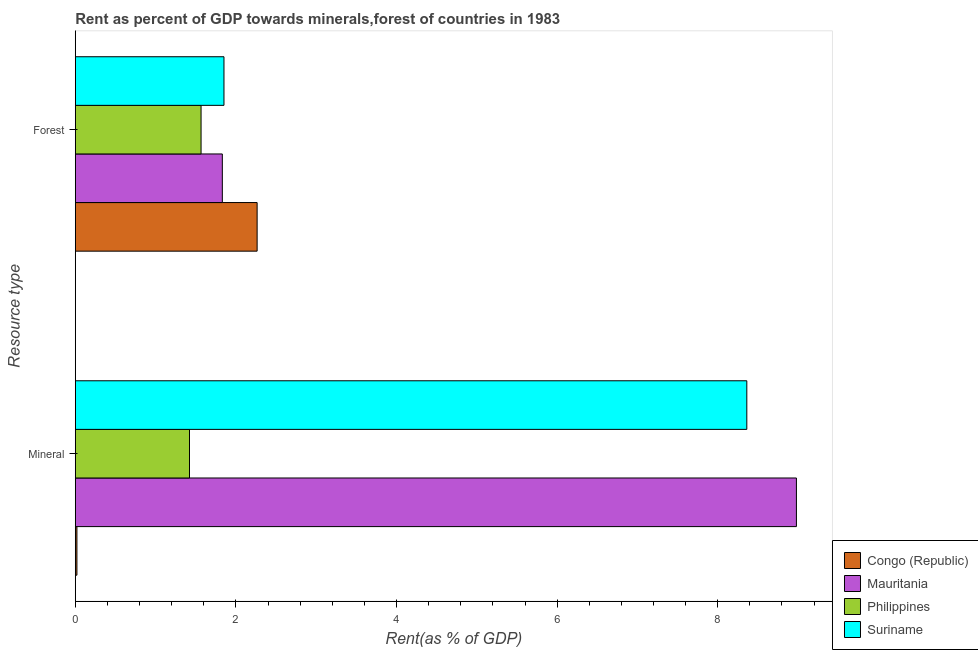Are the number of bars per tick equal to the number of legend labels?
Provide a succinct answer. Yes. How many bars are there on the 1st tick from the bottom?
Your answer should be compact. 4. What is the label of the 1st group of bars from the top?
Your answer should be compact. Forest. What is the forest rent in Suriname?
Your answer should be compact. 1.85. Across all countries, what is the maximum forest rent?
Your response must be concise. 2.26. Across all countries, what is the minimum forest rent?
Make the answer very short. 1.57. In which country was the forest rent maximum?
Offer a terse response. Congo (Republic). What is the total forest rent in the graph?
Your answer should be compact. 7.51. What is the difference between the forest rent in Suriname and that in Congo (Republic)?
Make the answer very short. -0.41. What is the difference between the forest rent in Philippines and the mineral rent in Suriname?
Ensure brevity in your answer.  -6.8. What is the average mineral rent per country?
Offer a terse response. 4.7. What is the difference between the mineral rent and forest rent in Mauritania?
Make the answer very short. 7.15. What is the ratio of the forest rent in Mauritania to that in Philippines?
Offer a terse response. 1.17. In how many countries, is the mineral rent greater than the average mineral rent taken over all countries?
Your response must be concise. 2. What does the 2nd bar from the bottom in Forest represents?
Your answer should be compact. Mauritania. How many bars are there?
Ensure brevity in your answer.  8. Are the values on the major ticks of X-axis written in scientific E-notation?
Make the answer very short. No. Does the graph contain grids?
Your response must be concise. No. Where does the legend appear in the graph?
Give a very brief answer. Bottom right. How many legend labels are there?
Your answer should be compact. 4. How are the legend labels stacked?
Provide a short and direct response. Vertical. What is the title of the graph?
Offer a terse response. Rent as percent of GDP towards minerals,forest of countries in 1983. What is the label or title of the X-axis?
Provide a short and direct response. Rent(as % of GDP). What is the label or title of the Y-axis?
Your response must be concise. Resource type. What is the Rent(as % of GDP) in Congo (Republic) in Mineral?
Your answer should be compact. 0.02. What is the Rent(as % of GDP) of Mauritania in Mineral?
Offer a terse response. 8.98. What is the Rent(as % of GDP) in Philippines in Mineral?
Provide a short and direct response. 1.42. What is the Rent(as % of GDP) in Suriname in Mineral?
Offer a terse response. 8.36. What is the Rent(as % of GDP) in Congo (Republic) in Forest?
Offer a very short reply. 2.26. What is the Rent(as % of GDP) of Mauritania in Forest?
Ensure brevity in your answer.  1.83. What is the Rent(as % of GDP) in Philippines in Forest?
Give a very brief answer. 1.57. What is the Rent(as % of GDP) of Suriname in Forest?
Provide a short and direct response. 1.85. Across all Resource type, what is the maximum Rent(as % of GDP) in Congo (Republic)?
Your response must be concise. 2.26. Across all Resource type, what is the maximum Rent(as % of GDP) in Mauritania?
Provide a succinct answer. 8.98. Across all Resource type, what is the maximum Rent(as % of GDP) in Philippines?
Your response must be concise. 1.57. Across all Resource type, what is the maximum Rent(as % of GDP) of Suriname?
Your answer should be very brief. 8.36. Across all Resource type, what is the minimum Rent(as % of GDP) in Congo (Republic)?
Your answer should be compact. 0.02. Across all Resource type, what is the minimum Rent(as % of GDP) of Mauritania?
Offer a very short reply. 1.83. Across all Resource type, what is the minimum Rent(as % of GDP) of Philippines?
Keep it short and to the point. 1.42. Across all Resource type, what is the minimum Rent(as % of GDP) in Suriname?
Your answer should be compact. 1.85. What is the total Rent(as % of GDP) of Congo (Republic) in the graph?
Provide a short and direct response. 2.28. What is the total Rent(as % of GDP) in Mauritania in the graph?
Offer a very short reply. 10.81. What is the total Rent(as % of GDP) in Philippines in the graph?
Offer a terse response. 2.99. What is the total Rent(as % of GDP) in Suriname in the graph?
Your response must be concise. 10.21. What is the difference between the Rent(as % of GDP) of Congo (Republic) in Mineral and that in Forest?
Ensure brevity in your answer.  -2.24. What is the difference between the Rent(as % of GDP) of Mauritania in Mineral and that in Forest?
Provide a succinct answer. 7.15. What is the difference between the Rent(as % of GDP) in Philippines in Mineral and that in Forest?
Provide a succinct answer. -0.14. What is the difference between the Rent(as % of GDP) of Suriname in Mineral and that in Forest?
Your response must be concise. 6.51. What is the difference between the Rent(as % of GDP) of Congo (Republic) in Mineral and the Rent(as % of GDP) of Mauritania in Forest?
Your answer should be very brief. -1.81. What is the difference between the Rent(as % of GDP) in Congo (Republic) in Mineral and the Rent(as % of GDP) in Philippines in Forest?
Offer a terse response. -1.55. What is the difference between the Rent(as % of GDP) in Congo (Republic) in Mineral and the Rent(as % of GDP) in Suriname in Forest?
Make the answer very short. -1.83. What is the difference between the Rent(as % of GDP) in Mauritania in Mineral and the Rent(as % of GDP) in Philippines in Forest?
Make the answer very short. 7.41. What is the difference between the Rent(as % of GDP) of Mauritania in Mineral and the Rent(as % of GDP) of Suriname in Forest?
Give a very brief answer. 7.13. What is the difference between the Rent(as % of GDP) in Philippines in Mineral and the Rent(as % of GDP) in Suriname in Forest?
Provide a short and direct response. -0.43. What is the average Rent(as % of GDP) in Congo (Republic) per Resource type?
Your answer should be compact. 1.14. What is the average Rent(as % of GDP) of Mauritania per Resource type?
Ensure brevity in your answer.  5.41. What is the average Rent(as % of GDP) in Philippines per Resource type?
Make the answer very short. 1.49. What is the average Rent(as % of GDP) in Suriname per Resource type?
Your response must be concise. 5.11. What is the difference between the Rent(as % of GDP) in Congo (Republic) and Rent(as % of GDP) in Mauritania in Mineral?
Provide a short and direct response. -8.96. What is the difference between the Rent(as % of GDP) of Congo (Republic) and Rent(as % of GDP) of Philippines in Mineral?
Give a very brief answer. -1.4. What is the difference between the Rent(as % of GDP) in Congo (Republic) and Rent(as % of GDP) in Suriname in Mineral?
Your answer should be compact. -8.34. What is the difference between the Rent(as % of GDP) in Mauritania and Rent(as % of GDP) in Philippines in Mineral?
Make the answer very short. 7.56. What is the difference between the Rent(as % of GDP) of Mauritania and Rent(as % of GDP) of Suriname in Mineral?
Ensure brevity in your answer.  0.62. What is the difference between the Rent(as % of GDP) in Philippines and Rent(as % of GDP) in Suriname in Mineral?
Your answer should be very brief. -6.94. What is the difference between the Rent(as % of GDP) of Congo (Republic) and Rent(as % of GDP) of Mauritania in Forest?
Keep it short and to the point. 0.43. What is the difference between the Rent(as % of GDP) in Congo (Republic) and Rent(as % of GDP) in Philippines in Forest?
Provide a short and direct response. 0.7. What is the difference between the Rent(as % of GDP) of Congo (Republic) and Rent(as % of GDP) of Suriname in Forest?
Give a very brief answer. 0.41. What is the difference between the Rent(as % of GDP) of Mauritania and Rent(as % of GDP) of Philippines in Forest?
Your response must be concise. 0.26. What is the difference between the Rent(as % of GDP) in Mauritania and Rent(as % of GDP) in Suriname in Forest?
Give a very brief answer. -0.02. What is the difference between the Rent(as % of GDP) in Philippines and Rent(as % of GDP) in Suriname in Forest?
Give a very brief answer. -0.29. What is the ratio of the Rent(as % of GDP) in Congo (Republic) in Mineral to that in Forest?
Your response must be concise. 0.01. What is the ratio of the Rent(as % of GDP) in Mauritania in Mineral to that in Forest?
Your answer should be very brief. 4.9. What is the ratio of the Rent(as % of GDP) in Philippines in Mineral to that in Forest?
Your response must be concise. 0.91. What is the ratio of the Rent(as % of GDP) in Suriname in Mineral to that in Forest?
Provide a short and direct response. 4.52. What is the difference between the highest and the second highest Rent(as % of GDP) of Congo (Republic)?
Provide a short and direct response. 2.24. What is the difference between the highest and the second highest Rent(as % of GDP) of Mauritania?
Offer a very short reply. 7.15. What is the difference between the highest and the second highest Rent(as % of GDP) of Philippines?
Provide a short and direct response. 0.14. What is the difference between the highest and the second highest Rent(as % of GDP) in Suriname?
Offer a terse response. 6.51. What is the difference between the highest and the lowest Rent(as % of GDP) in Congo (Republic)?
Your response must be concise. 2.24. What is the difference between the highest and the lowest Rent(as % of GDP) in Mauritania?
Your answer should be compact. 7.15. What is the difference between the highest and the lowest Rent(as % of GDP) of Philippines?
Your answer should be compact. 0.14. What is the difference between the highest and the lowest Rent(as % of GDP) of Suriname?
Offer a very short reply. 6.51. 